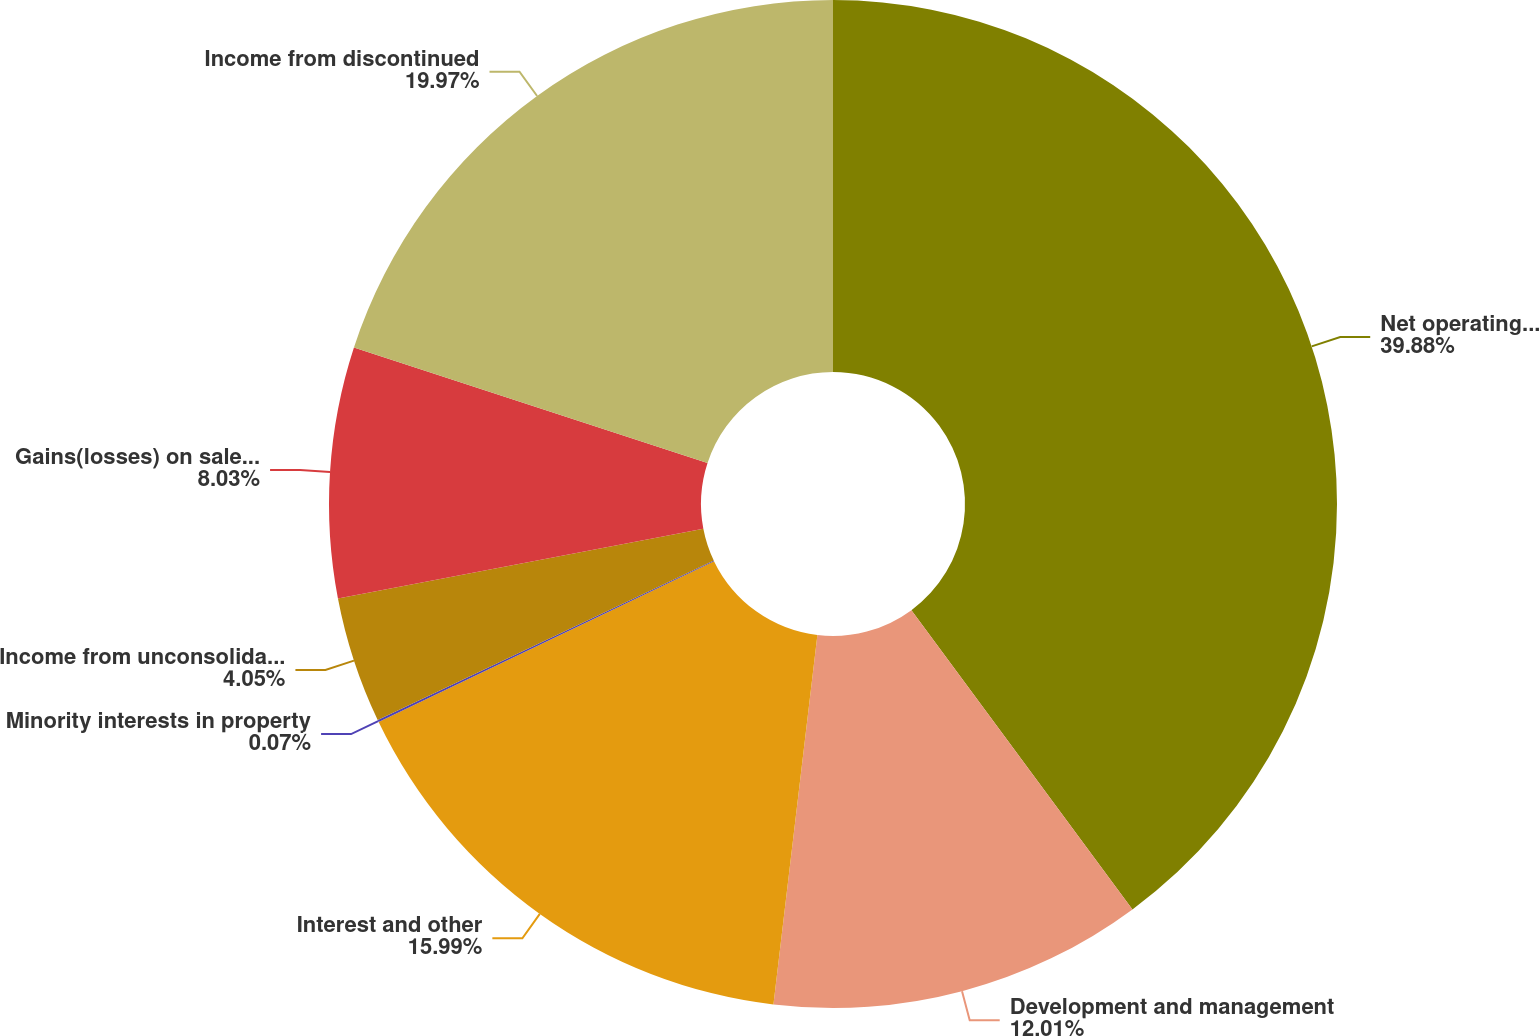<chart> <loc_0><loc_0><loc_500><loc_500><pie_chart><fcel>Net operating income<fcel>Development and management<fcel>Interest and other<fcel>Minority interests in property<fcel>Income from unconsolidated<fcel>Gains(losses) on sales of real<fcel>Income from discontinued<nl><fcel>39.87%<fcel>12.01%<fcel>15.99%<fcel>0.07%<fcel>4.05%<fcel>8.03%<fcel>19.97%<nl></chart> 